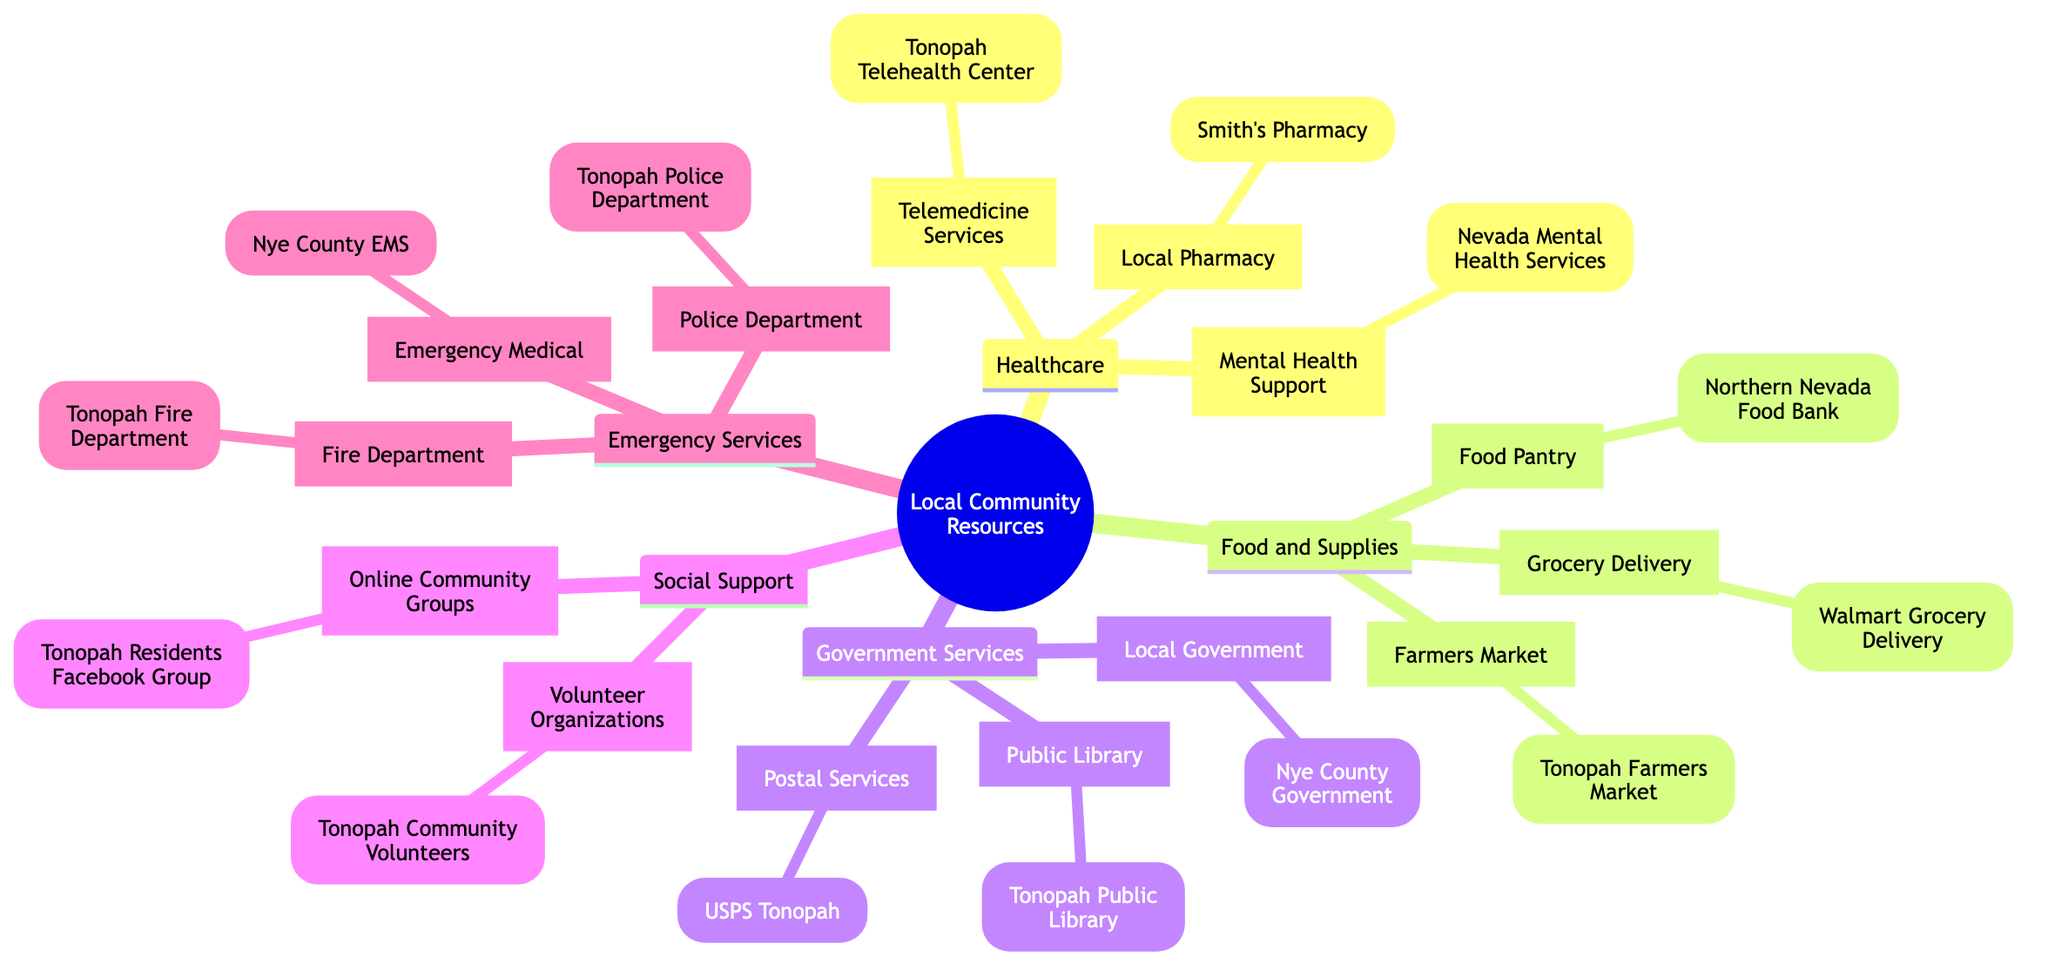What healthcare service is listed under Telemedicine Services? The diagram indicates the service provided under Telemedicine Services is the Tonopah Telehealth Center. It is a direct answer derived from the healthcare section.
Answer: Tonopah Telehealth Center How many types of community resources are shown in the diagram? The diagram consists of five main categories: Healthcare, Food and Supplies, Government Services, Social Support, and Emergency Services. Counting these categories gives us a total of five.
Answer: 5 Which organization provides food pantry services? Within the Food and Supplies category, the organization identified for food pantry services is the Northern Nevada Food Bank. This specific information can be directly referenced from the diagram.
Answer: Northern Nevada Food Bank What is the relationship between Emergency Services and Healthcare in the diagram? The relationship depicted in the diagram shows that both Emergency Services and Healthcare are distinct categories of Local Community Resources. They stand alongside each other as separate entities under the main root concept. Therefore, they are both aspects of community support but cater to different needs.
Answer: Both are distinct categories List one volunteer organization mentioned in the diagram. The diagram points out that the Tonopah Community Volunteers are labeled under the Social Support category as a volunteer organization. It refers specifically to this resource.
Answer: Tonopah Community Volunteers What service does the Tonopah Public Library provide? The Tonopah Public Library falls under the Government Services category. It functions as a public library, offering local residents various resources related to information and literature. This fact is clearly stated in the diagram.
Answer: Public Library How many emergency services are listed in the diagram? Under the Emergency Services category, there are three listed services: the Tonopah Police Department, Tonopah Fire Department, and Nye County EMS. Counting these services gives a total of three.
Answer: 3 What type of grocery service is provided by Walmart? According to the diagram under the Food and Supplies section, Walmart is specifically mentioned for its Grocery Delivery service. This is a straightforward retrieval from the diagram.
Answer: Grocery Delivery Which group provides mental health support in the community? The diagram indicates that Nevada Mental Health Services provides mental health support. This corresponds to the healthcare sector, where it is explicitly mentioned as a designated service available.
Answer: Nevada Mental Health Services 